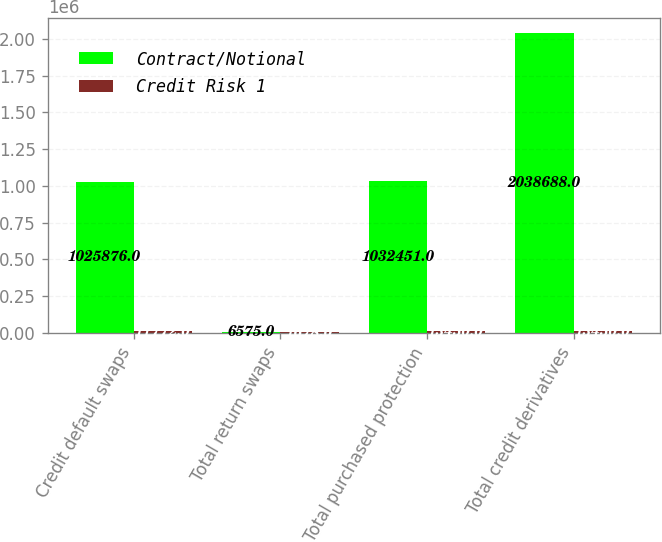Convert chart to OTSL. <chart><loc_0><loc_0><loc_500><loc_500><stacked_bar_chart><ecel><fcel>Credit default swaps<fcel>Total return swaps<fcel>Total purchased protection<fcel>Total credit derivatives<nl><fcel>Contract/Notional<fcel>1.02588e+06<fcel>6575<fcel>1.03245e+06<fcel>2.03869e+06<nl><fcel>Credit Risk 1<fcel>11772<fcel>1678<fcel>13450<fcel>13450<nl></chart> 